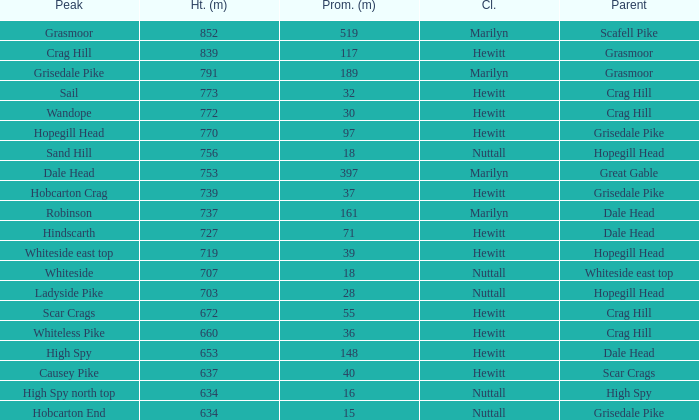Which Class is Peak Sail when it has a Prom larger than 30? Hewitt. 